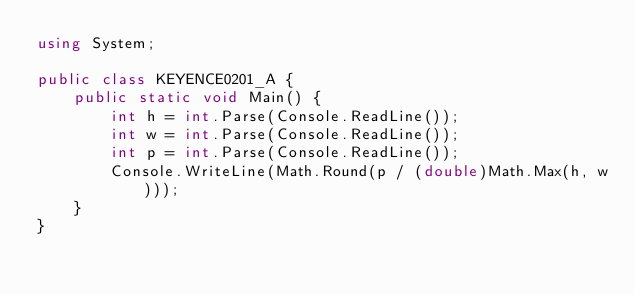Convert code to text. <code><loc_0><loc_0><loc_500><loc_500><_C#_>using System;

public class KEYENCE0201_A {
    public static void Main() {
        int h = int.Parse(Console.ReadLine());
        int w = int.Parse(Console.ReadLine());
        int p = int.Parse(Console.ReadLine());
        Console.WriteLine(Math.Round(p / (double)Math.Max(h, w)));
    }
}</code> 